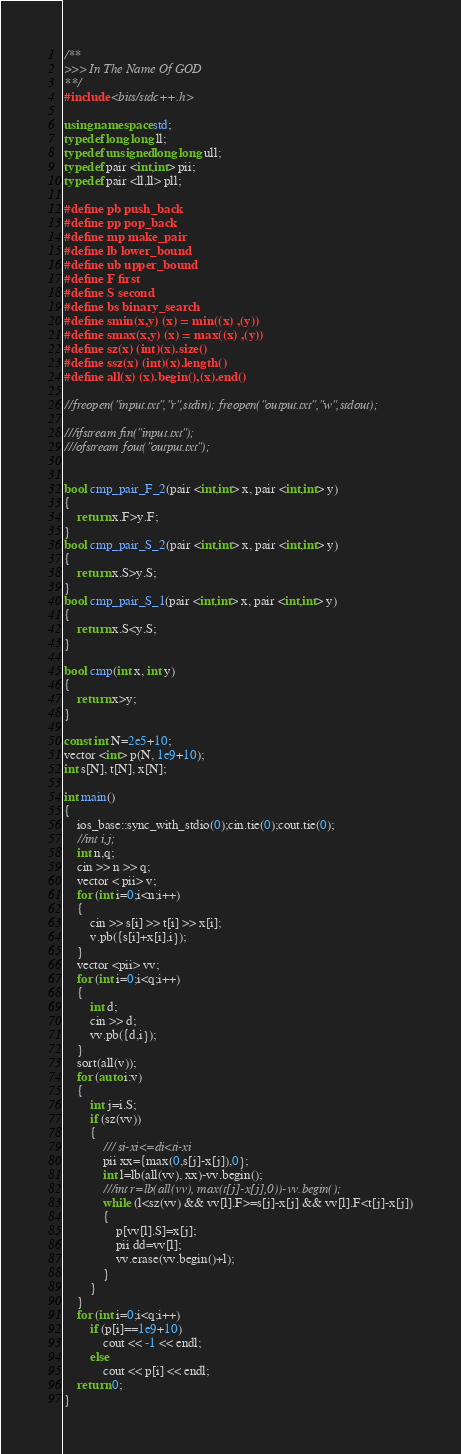Convert code to text. <code><loc_0><loc_0><loc_500><loc_500><_C++_>/**
>>> In The Name Of GOD
**/
#include <bits/stdc++.h>

using namespace std;
typedef long long ll;
typedef unsigned long long ull;
typedef pair <int,int> pii;
typedef pair <ll,ll> pll;

#define pb push_back
#define pp pop_back
#define mp make_pair
#define lb lower_bound
#define ub upper_bound
#define F first
#define S second
#define bs binary_search
#define smin(x,y) (x) = min((x) ,(y))
#define smax(x,y) (x) = max((x) ,(y))
#define sz(x) (int)(x).size()
#define ssz(x) (int)(x).length()
#define all(x) (x).begin(),(x).end()

//freopen("input.txt","r",stdin); freopen("output.txt","w",stdout);

///ifstream fin("input.txt");
///ofstream fout("output.txt");


bool cmp_pair_F_2(pair <int,int> x, pair <int,int> y)
{
    return x.F>y.F;
}
bool cmp_pair_S_2(pair <int,int> x, pair <int,int> y)
{
    return x.S>y.S;
}
bool cmp_pair_S_1(pair <int,int> x, pair <int,int> y)
{
    return x.S<y.S;
}

bool cmp(int x, int y)
{
	return x>y;
}

const int N=2e5+10;
vector <int> p(N, 1e9+10);
int s[N], t[N], x[N];

int main()
{
    ios_base::sync_with_stdio(0);cin.tie(0);cout.tie(0);
    //int i,j;
	int n,q;
	cin >> n >> q;
	vector < pii> v;
	for (int i=0;i<n;i++)
    {
        cin >> s[i] >> t[i] >> x[i];
        v.pb({s[i]+x[i],i});
    }
    vector <pii> vv;
    for (int i=0;i<q;i++)
    {
        int d;
        cin >> d;
        vv.pb({d,i});
    }
    sort(all(v));
    for (auto i:v)
    {
        int j=i.S;
        if (sz(vv))
        {
            /// si-xi<=di<ti-xi
            pii xx={max(0,s[j]-x[j]),0};
            int l=lb(all(vv), xx)-vv.begin();
            ///int r=lb(all(vv), max(t[j]-x[j],0))-vv.begin();
            while (l<sz(vv) && vv[l].F>=s[j]-x[j] && vv[l].F<t[j]-x[j])
            {
                p[vv[l].S]=x[j];
                pii dd=vv[l];
                vv.erase(vv.begin()+l);
            }
        }
    }
    for (int i=0;i<q;i++)
        if (p[i]==1e9+10)
            cout << -1 << endl;
        else
            cout << p[i] << endl;
    return 0;
}
</code> 